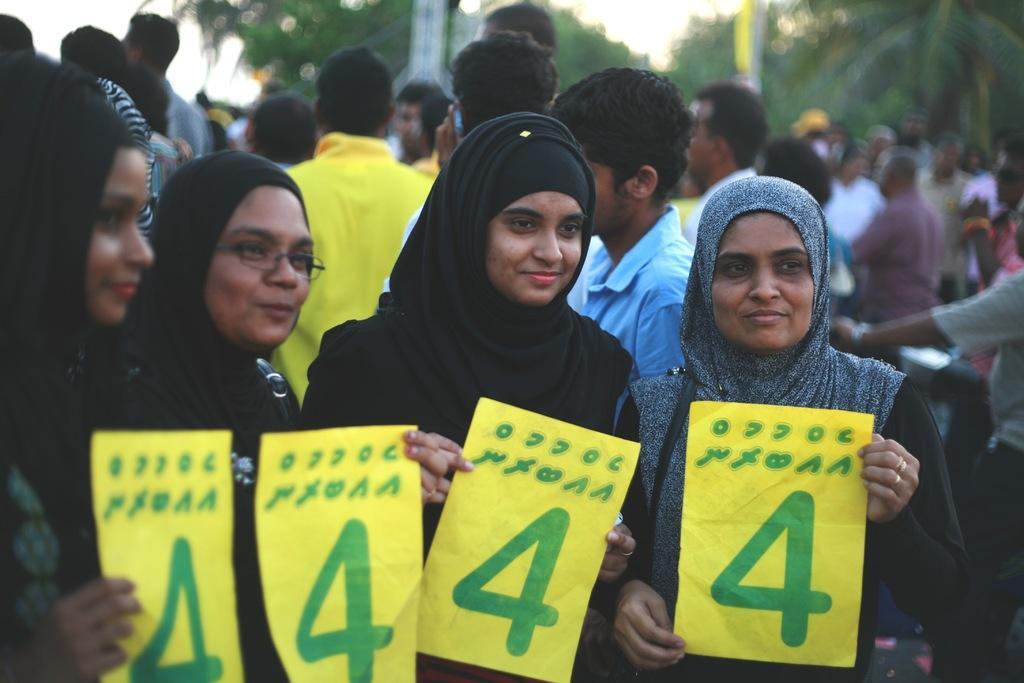Please provide a concise description of this image. In this image we can see people holding papers in their hands and behind them, we can see trees, poles and people standing. 